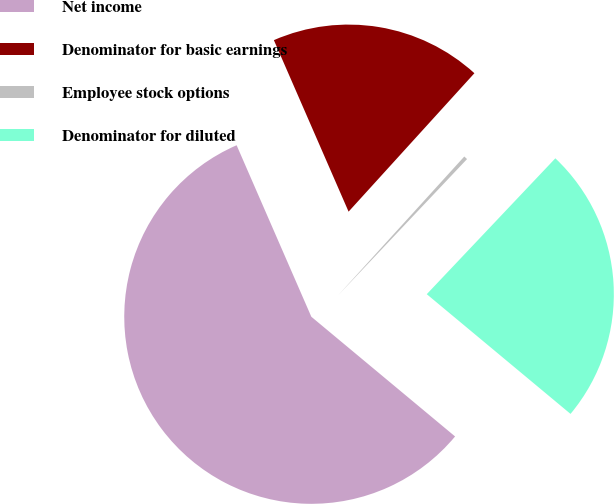Convert chart to OTSL. <chart><loc_0><loc_0><loc_500><loc_500><pie_chart><fcel>Net income<fcel>Denominator for basic earnings<fcel>Employee stock options<fcel>Denominator for diluted<nl><fcel>57.41%<fcel>18.28%<fcel>0.32%<fcel>23.99%<nl></chart> 